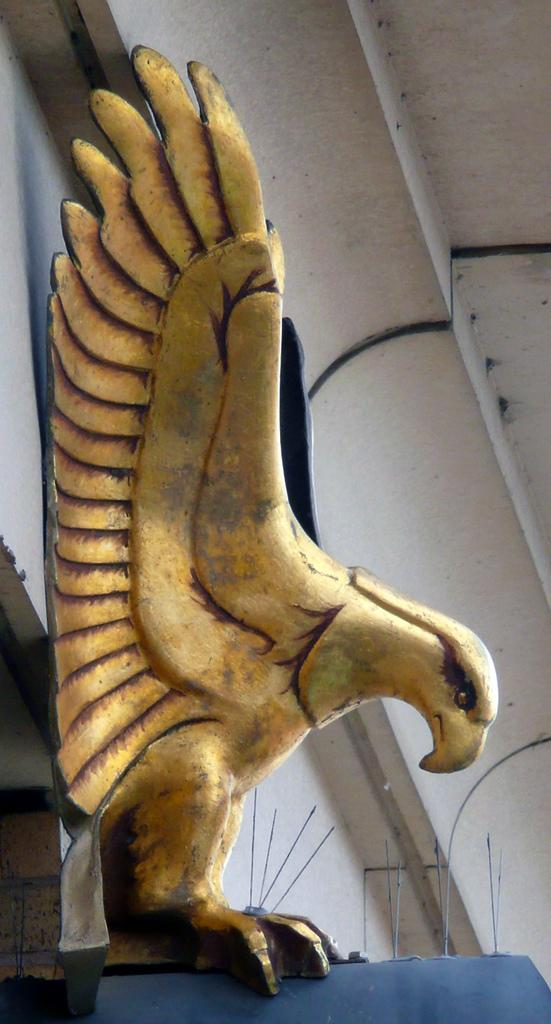What type of birds are depicted on the wall in the image? There are yellow eagles on the wall in the image. What structure is visible in the image? There is a roof visible in the image. How many receipts can be seen on the wall with the yellow eagles in the image? There are no receipts present in the image; it only features yellow eagles on the wall. Can you describe the movement of the eagles in the image? The eagles in the image are not moving, as it is a static image. 